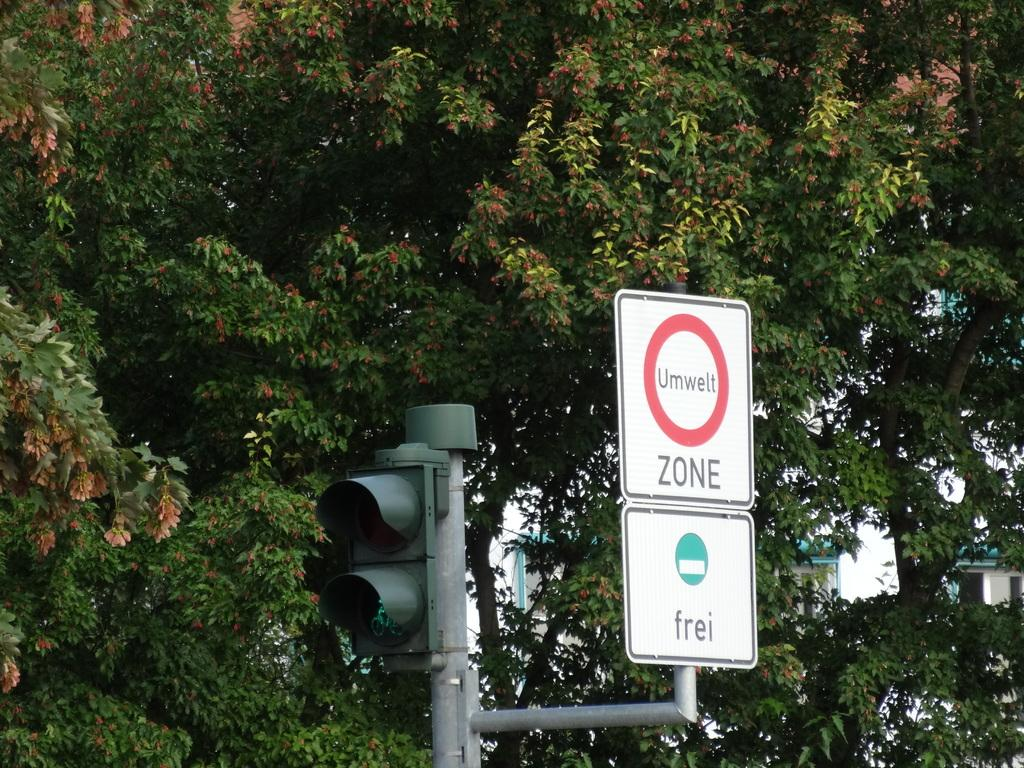<image>
Present a compact description of the photo's key features. A sign reads "Umwelt Zone" by a traffic light. 